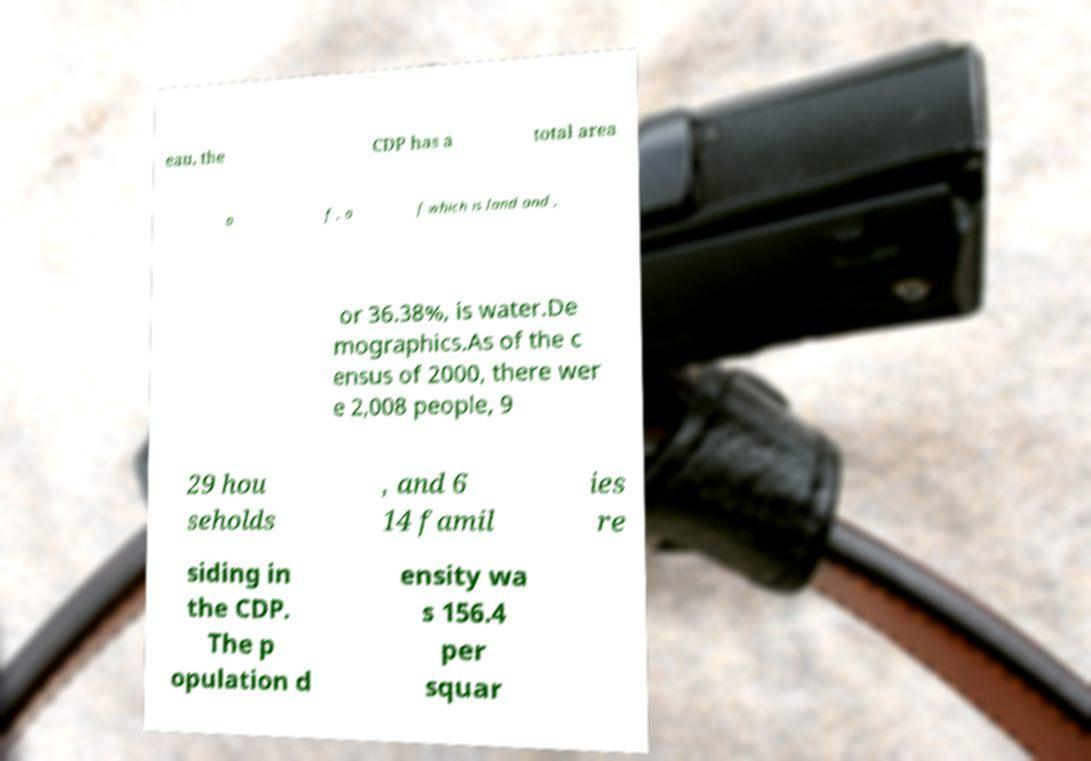I need the written content from this picture converted into text. Can you do that? eau, the CDP has a total area o f , o f which is land and , or 36.38%, is water.De mographics.As of the c ensus of 2000, there wer e 2,008 people, 9 29 hou seholds , and 6 14 famil ies re siding in the CDP. The p opulation d ensity wa s 156.4 per squar 